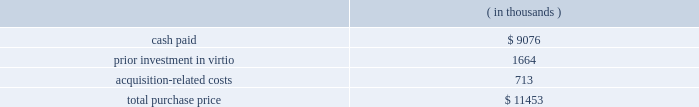Fair value of the tangible assets and identifiable intangible assets acquired , was $ 17.7 million .
Goodwill resulted primarily from the company 2019s expectation of synergies from the integration of sigma-c 2019s technology with the company 2019s technology and operations .
Virtio corporation , inc .
( virtio ) the company acquired virtio on may 15 , 2006 in an all-cash transaction .
Reasons for the acquisition .
The company believes that its acquisition of virtio will expand its presence in electronic system level design .
The company expects the combination of the company 2019s system studio solution with virtio 2019s virtual prototyping technology will help accelerate systems to market by giving software developers the ability to begin code development earlier than with prevailing methods .
Purchase price .
The company paid $ 9.1 million in cash for the outstanding shares of virtio , of which $ 0.9 million was deposited with an escrow agent and which will be paid to the former stockholders of virtio pursuant to the terms of an escrow agreement .
In addition , the company had a prior investment in virtio of approximately $ 1.7 million .
The total purchase consideration consisted of: .
Acquisition-related costs of $ 0.7 million consist primarily of legal , tax and accounting fees , estimated facilities closure costs and employee termination costs .
As of october 31 , 2006 , the company had paid $ 0.3 million of the acquisition-related costs .
The $ 0.4 million balance remaining at october 31 , 2006 primarily consists of professional and tax-related service fees and facilities closure costs .
Under the agreement with virtio , the company has also agreed to pay up to $ 4.3 million over three years to the former stockholders based upon achievement of certain sales milestones .
This contingent consideration is considered to be additional purchase price and will be an adjustment to goodwill when and if payment is made .
Additionally , the company has also agreed to pay $ 0.9 million in employee retention bonuses which will be recognized as compensation expense over the service period of the applicable employees .
Assets acquired .
The company has performed a preliminary valuation and allocated the total purchase consideration to the assets and liabilities acquired , including identifiable intangible assets based on their respective fair values on the acquisition date .
The company acquired $ 2.5 million of intangible assets consisting of $ 1.9 million in existing technology , $ 0.4 million in customer relationships and $ 0.2 million in non-compete agreements to be amortized over five to seven years .
Additionally , the company acquired tangible assets of $ 5.5 million and assumed liabilities of $ 3.2 million .
Goodwill , representing the excess of the purchase price over the fair value of the net tangible and identifiable intangible assets acquired in the merger , was $ 6.7 million .
Goodwill resulted primarily from the company 2019s expectation of synergies from the integration of virtio 2019s technology with the company 2019s technology and operations .
Hpl technologies , inc .
( hpl ) the company acquired hpl on december 7 , 2005 in an all-cash transaction .
Reasons for the acquisition .
The company believes that the acquisition of hpl will help solidify the company 2019s position as a leading electronic design automation vendor in design for manufacturing ( dfm ) .
What percentage of the total purchase price did intangible assets represent? 
Computations: ((2.5 * 1000) / 11453)
Answer: 0.21828. Fair value of the tangible assets and identifiable intangible assets acquired , was $ 17.7 million .
Goodwill resulted primarily from the company 2019s expectation of synergies from the integration of sigma-c 2019s technology with the company 2019s technology and operations .
Virtio corporation , inc .
( virtio ) the company acquired virtio on may 15 , 2006 in an all-cash transaction .
Reasons for the acquisition .
The company believes that its acquisition of virtio will expand its presence in electronic system level design .
The company expects the combination of the company 2019s system studio solution with virtio 2019s virtual prototyping technology will help accelerate systems to market by giving software developers the ability to begin code development earlier than with prevailing methods .
Purchase price .
The company paid $ 9.1 million in cash for the outstanding shares of virtio , of which $ 0.9 million was deposited with an escrow agent and which will be paid to the former stockholders of virtio pursuant to the terms of an escrow agreement .
In addition , the company had a prior investment in virtio of approximately $ 1.7 million .
The total purchase consideration consisted of: .
Acquisition-related costs of $ 0.7 million consist primarily of legal , tax and accounting fees , estimated facilities closure costs and employee termination costs .
As of october 31 , 2006 , the company had paid $ 0.3 million of the acquisition-related costs .
The $ 0.4 million balance remaining at october 31 , 2006 primarily consists of professional and tax-related service fees and facilities closure costs .
Under the agreement with virtio , the company has also agreed to pay up to $ 4.3 million over three years to the former stockholders based upon achievement of certain sales milestones .
This contingent consideration is considered to be additional purchase price and will be an adjustment to goodwill when and if payment is made .
Additionally , the company has also agreed to pay $ 0.9 million in employee retention bonuses which will be recognized as compensation expense over the service period of the applicable employees .
Assets acquired .
The company has performed a preliminary valuation and allocated the total purchase consideration to the assets and liabilities acquired , including identifiable intangible assets based on their respective fair values on the acquisition date .
The company acquired $ 2.5 million of intangible assets consisting of $ 1.9 million in existing technology , $ 0.4 million in customer relationships and $ 0.2 million in non-compete agreements to be amortized over five to seven years .
Additionally , the company acquired tangible assets of $ 5.5 million and assumed liabilities of $ 3.2 million .
Goodwill , representing the excess of the purchase price over the fair value of the net tangible and identifiable intangible assets acquired in the merger , was $ 6.7 million .
Goodwill resulted primarily from the company 2019s expectation of synergies from the integration of virtio 2019s technology with the company 2019s technology and operations .
Hpl technologies , inc .
( hpl ) the company acquired hpl on december 7 , 2005 in an all-cash transaction .
Reasons for the acquisition .
The company believes that the acquisition of hpl will help solidify the company 2019s position as a leading electronic design automation vendor in design for manufacturing ( dfm ) .
What is the percentage of cash paid among the total purchase price? 
Rationale: it is the value of cash paid divided by the total purchase price , then turned into a percentage .
Computations: (9076 / 11453)
Answer: 0.79246. 